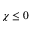<formula> <loc_0><loc_0><loc_500><loc_500>\chi \leq 0</formula> 